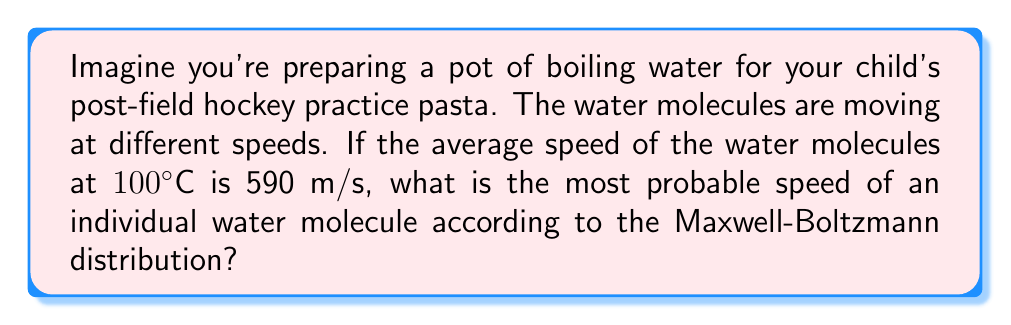Can you solve this math problem? To solve this problem, we'll use the relationship between the average speed and the most probable speed in the Maxwell-Boltzmann distribution. Here's how we can approach it:

1. The Maxwell-Boltzmann distribution describes the speeds of molecules in a gas or liquid.

2. In this distribution, there are three important speeds:
   - Most probable speed ($v_p$)
   - Average speed ($\bar{v}$)
   - Root mean square speed ($v_{rms}$)

3. These speeds are related by the following ratios:
   $$\frac{v_p}{\bar{v}} = \sqrt{\frac{8}{3\pi}} \approx 0.921$$

4. We are given that the average speed $\bar{v} = 590$ m/s.

5. To find the most probable speed $v_p$, we can use the ratio:
   $$v_p = \bar{v} \cdot \sqrt{\frac{8}{3\pi}}$$

6. Substituting the values:
   $$v_p = 590 \cdot \sqrt{\frac{8}{3\pi}} \approx 590 \cdot 0.921 \approx 543.39 \text{ m/s}$$

7. Rounding to the nearest whole number, we get 543 m/s.

This means that while the water molecules have an average speed of 590 m/s, the speed you're most likely to measure if you could observe an individual molecule is about 543 m/s.
Answer: 543 m/s 